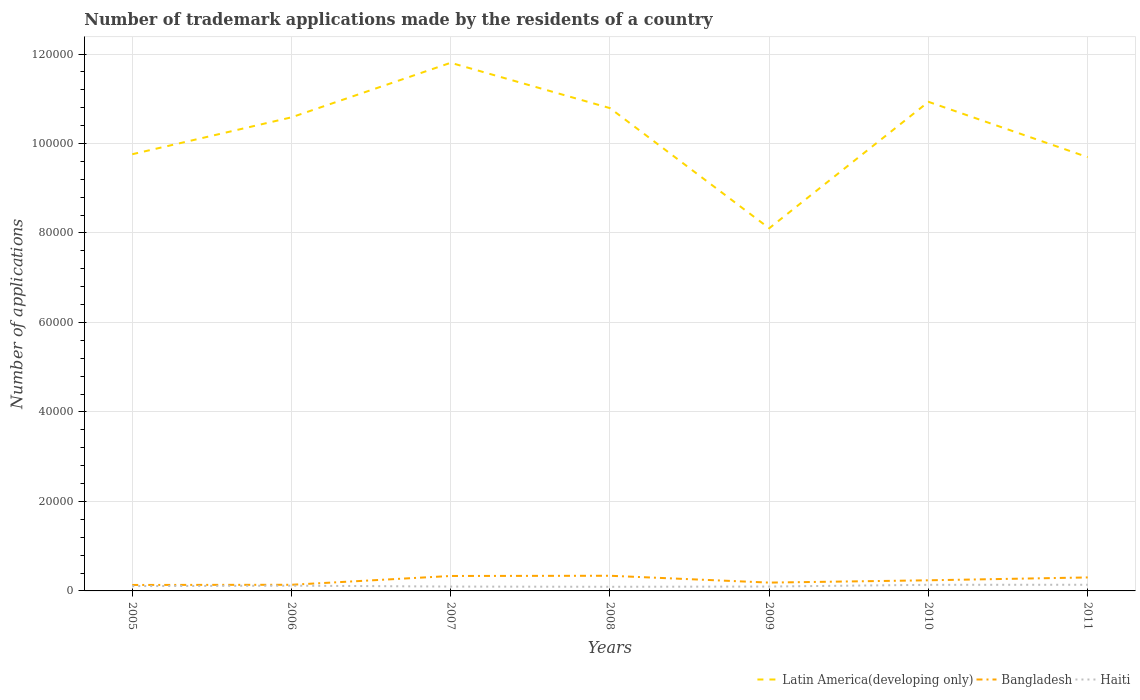Is the number of lines equal to the number of legend labels?
Make the answer very short. Yes. Across all years, what is the maximum number of trademark applications made by the residents in Latin America(developing only)?
Offer a very short reply. 8.11e+04. In which year was the number of trademark applications made by the residents in Bangladesh maximum?
Offer a very short reply. 2005. What is the total number of trademark applications made by the residents in Haiti in the graph?
Make the answer very short. 248. What is the difference between the highest and the second highest number of trademark applications made by the residents in Haiti?
Your answer should be compact. 452. What is the difference between the highest and the lowest number of trademark applications made by the residents in Bangladesh?
Give a very brief answer. 3. Is the number of trademark applications made by the residents in Bangladesh strictly greater than the number of trademark applications made by the residents in Haiti over the years?
Your answer should be very brief. No. How many years are there in the graph?
Give a very brief answer. 7. Are the values on the major ticks of Y-axis written in scientific E-notation?
Give a very brief answer. No. Does the graph contain any zero values?
Offer a terse response. No. Does the graph contain grids?
Keep it short and to the point. Yes. Where does the legend appear in the graph?
Your answer should be compact. Bottom right. How many legend labels are there?
Give a very brief answer. 3. How are the legend labels stacked?
Your response must be concise. Horizontal. What is the title of the graph?
Provide a short and direct response. Number of trademark applications made by the residents of a country. What is the label or title of the Y-axis?
Your answer should be compact. Number of applications. What is the Number of applications in Latin America(developing only) in 2005?
Offer a terse response. 9.76e+04. What is the Number of applications of Bangladesh in 2005?
Offer a very short reply. 1332. What is the Number of applications in Haiti in 2005?
Provide a succinct answer. 1079. What is the Number of applications of Latin America(developing only) in 2006?
Your answer should be compact. 1.06e+05. What is the Number of applications in Bangladesh in 2006?
Your answer should be compact. 1374. What is the Number of applications of Haiti in 2006?
Make the answer very short. 1173. What is the Number of applications in Latin America(developing only) in 2007?
Your response must be concise. 1.18e+05. What is the Number of applications in Bangladesh in 2007?
Offer a terse response. 3341. What is the Number of applications in Haiti in 2007?
Provide a succinct answer. 973. What is the Number of applications of Latin America(developing only) in 2008?
Keep it short and to the point. 1.08e+05. What is the Number of applications in Bangladesh in 2008?
Ensure brevity in your answer.  3388. What is the Number of applications in Haiti in 2008?
Ensure brevity in your answer.  925. What is the Number of applications of Latin America(developing only) in 2009?
Ensure brevity in your answer.  8.11e+04. What is the Number of applications in Bangladesh in 2009?
Provide a succinct answer. 1859. What is the Number of applications of Haiti in 2009?
Keep it short and to the point. 981. What is the Number of applications of Latin America(developing only) in 2010?
Offer a very short reply. 1.09e+05. What is the Number of applications of Bangladesh in 2010?
Your response must be concise. 2374. What is the Number of applications in Haiti in 2010?
Make the answer very short. 1365. What is the Number of applications in Latin America(developing only) in 2011?
Provide a succinct answer. 9.69e+04. What is the Number of applications of Bangladesh in 2011?
Give a very brief answer. 3013. What is the Number of applications in Haiti in 2011?
Offer a terse response. 1377. Across all years, what is the maximum Number of applications in Latin America(developing only)?
Ensure brevity in your answer.  1.18e+05. Across all years, what is the maximum Number of applications of Bangladesh?
Your response must be concise. 3388. Across all years, what is the maximum Number of applications in Haiti?
Ensure brevity in your answer.  1377. Across all years, what is the minimum Number of applications of Latin America(developing only)?
Make the answer very short. 8.11e+04. Across all years, what is the minimum Number of applications of Bangladesh?
Make the answer very short. 1332. Across all years, what is the minimum Number of applications of Haiti?
Provide a succinct answer. 925. What is the total Number of applications of Latin America(developing only) in the graph?
Your response must be concise. 7.17e+05. What is the total Number of applications of Bangladesh in the graph?
Your answer should be very brief. 1.67e+04. What is the total Number of applications of Haiti in the graph?
Keep it short and to the point. 7873. What is the difference between the Number of applications in Latin America(developing only) in 2005 and that in 2006?
Keep it short and to the point. -8250. What is the difference between the Number of applications in Bangladesh in 2005 and that in 2006?
Make the answer very short. -42. What is the difference between the Number of applications in Haiti in 2005 and that in 2006?
Make the answer very short. -94. What is the difference between the Number of applications of Latin America(developing only) in 2005 and that in 2007?
Give a very brief answer. -2.04e+04. What is the difference between the Number of applications of Bangladesh in 2005 and that in 2007?
Offer a very short reply. -2009. What is the difference between the Number of applications in Haiti in 2005 and that in 2007?
Your response must be concise. 106. What is the difference between the Number of applications of Latin America(developing only) in 2005 and that in 2008?
Ensure brevity in your answer.  -1.03e+04. What is the difference between the Number of applications of Bangladesh in 2005 and that in 2008?
Make the answer very short. -2056. What is the difference between the Number of applications of Haiti in 2005 and that in 2008?
Your response must be concise. 154. What is the difference between the Number of applications of Latin America(developing only) in 2005 and that in 2009?
Your response must be concise. 1.65e+04. What is the difference between the Number of applications in Bangladesh in 2005 and that in 2009?
Keep it short and to the point. -527. What is the difference between the Number of applications of Haiti in 2005 and that in 2009?
Ensure brevity in your answer.  98. What is the difference between the Number of applications in Latin America(developing only) in 2005 and that in 2010?
Give a very brief answer. -1.17e+04. What is the difference between the Number of applications of Bangladesh in 2005 and that in 2010?
Ensure brevity in your answer.  -1042. What is the difference between the Number of applications in Haiti in 2005 and that in 2010?
Ensure brevity in your answer.  -286. What is the difference between the Number of applications in Latin America(developing only) in 2005 and that in 2011?
Offer a very short reply. 656. What is the difference between the Number of applications of Bangladesh in 2005 and that in 2011?
Give a very brief answer. -1681. What is the difference between the Number of applications of Haiti in 2005 and that in 2011?
Make the answer very short. -298. What is the difference between the Number of applications of Latin America(developing only) in 2006 and that in 2007?
Offer a terse response. -1.22e+04. What is the difference between the Number of applications in Bangladesh in 2006 and that in 2007?
Your answer should be compact. -1967. What is the difference between the Number of applications in Latin America(developing only) in 2006 and that in 2008?
Offer a terse response. -2057. What is the difference between the Number of applications in Bangladesh in 2006 and that in 2008?
Ensure brevity in your answer.  -2014. What is the difference between the Number of applications in Haiti in 2006 and that in 2008?
Your answer should be very brief. 248. What is the difference between the Number of applications in Latin America(developing only) in 2006 and that in 2009?
Your answer should be compact. 2.48e+04. What is the difference between the Number of applications in Bangladesh in 2006 and that in 2009?
Your answer should be very brief. -485. What is the difference between the Number of applications in Haiti in 2006 and that in 2009?
Your answer should be very brief. 192. What is the difference between the Number of applications of Latin America(developing only) in 2006 and that in 2010?
Make the answer very short. -3465. What is the difference between the Number of applications of Bangladesh in 2006 and that in 2010?
Provide a succinct answer. -1000. What is the difference between the Number of applications of Haiti in 2006 and that in 2010?
Your response must be concise. -192. What is the difference between the Number of applications of Latin America(developing only) in 2006 and that in 2011?
Your response must be concise. 8906. What is the difference between the Number of applications in Bangladesh in 2006 and that in 2011?
Ensure brevity in your answer.  -1639. What is the difference between the Number of applications in Haiti in 2006 and that in 2011?
Ensure brevity in your answer.  -204. What is the difference between the Number of applications in Latin America(developing only) in 2007 and that in 2008?
Your answer should be very brief. 1.01e+04. What is the difference between the Number of applications in Bangladesh in 2007 and that in 2008?
Your answer should be very brief. -47. What is the difference between the Number of applications of Latin America(developing only) in 2007 and that in 2009?
Make the answer very short. 3.70e+04. What is the difference between the Number of applications in Bangladesh in 2007 and that in 2009?
Provide a short and direct response. 1482. What is the difference between the Number of applications in Latin America(developing only) in 2007 and that in 2010?
Provide a short and direct response. 8728. What is the difference between the Number of applications of Bangladesh in 2007 and that in 2010?
Ensure brevity in your answer.  967. What is the difference between the Number of applications in Haiti in 2007 and that in 2010?
Provide a succinct answer. -392. What is the difference between the Number of applications of Latin America(developing only) in 2007 and that in 2011?
Offer a terse response. 2.11e+04. What is the difference between the Number of applications of Bangladesh in 2007 and that in 2011?
Your response must be concise. 328. What is the difference between the Number of applications of Haiti in 2007 and that in 2011?
Your response must be concise. -404. What is the difference between the Number of applications in Latin America(developing only) in 2008 and that in 2009?
Offer a very short reply. 2.69e+04. What is the difference between the Number of applications of Bangladesh in 2008 and that in 2009?
Make the answer very short. 1529. What is the difference between the Number of applications of Haiti in 2008 and that in 2009?
Your answer should be very brief. -56. What is the difference between the Number of applications in Latin America(developing only) in 2008 and that in 2010?
Offer a terse response. -1408. What is the difference between the Number of applications of Bangladesh in 2008 and that in 2010?
Give a very brief answer. 1014. What is the difference between the Number of applications of Haiti in 2008 and that in 2010?
Offer a terse response. -440. What is the difference between the Number of applications in Latin America(developing only) in 2008 and that in 2011?
Make the answer very short. 1.10e+04. What is the difference between the Number of applications of Bangladesh in 2008 and that in 2011?
Give a very brief answer. 375. What is the difference between the Number of applications of Haiti in 2008 and that in 2011?
Offer a very short reply. -452. What is the difference between the Number of applications of Latin America(developing only) in 2009 and that in 2010?
Provide a short and direct response. -2.83e+04. What is the difference between the Number of applications of Bangladesh in 2009 and that in 2010?
Your answer should be compact. -515. What is the difference between the Number of applications in Haiti in 2009 and that in 2010?
Your answer should be compact. -384. What is the difference between the Number of applications of Latin America(developing only) in 2009 and that in 2011?
Give a very brief answer. -1.59e+04. What is the difference between the Number of applications in Bangladesh in 2009 and that in 2011?
Make the answer very short. -1154. What is the difference between the Number of applications in Haiti in 2009 and that in 2011?
Offer a very short reply. -396. What is the difference between the Number of applications in Latin America(developing only) in 2010 and that in 2011?
Offer a very short reply. 1.24e+04. What is the difference between the Number of applications of Bangladesh in 2010 and that in 2011?
Offer a very short reply. -639. What is the difference between the Number of applications of Latin America(developing only) in 2005 and the Number of applications of Bangladesh in 2006?
Keep it short and to the point. 9.62e+04. What is the difference between the Number of applications of Latin America(developing only) in 2005 and the Number of applications of Haiti in 2006?
Your response must be concise. 9.64e+04. What is the difference between the Number of applications in Bangladesh in 2005 and the Number of applications in Haiti in 2006?
Keep it short and to the point. 159. What is the difference between the Number of applications in Latin America(developing only) in 2005 and the Number of applications in Bangladesh in 2007?
Your answer should be compact. 9.43e+04. What is the difference between the Number of applications in Latin America(developing only) in 2005 and the Number of applications in Haiti in 2007?
Offer a very short reply. 9.66e+04. What is the difference between the Number of applications in Bangladesh in 2005 and the Number of applications in Haiti in 2007?
Make the answer very short. 359. What is the difference between the Number of applications of Latin America(developing only) in 2005 and the Number of applications of Bangladesh in 2008?
Provide a short and direct response. 9.42e+04. What is the difference between the Number of applications in Latin America(developing only) in 2005 and the Number of applications in Haiti in 2008?
Offer a terse response. 9.67e+04. What is the difference between the Number of applications of Bangladesh in 2005 and the Number of applications of Haiti in 2008?
Offer a terse response. 407. What is the difference between the Number of applications of Latin America(developing only) in 2005 and the Number of applications of Bangladesh in 2009?
Your answer should be very brief. 9.57e+04. What is the difference between the Number of applications of Latin America(developing only) in 2005 and the Number of applications of Haiti in 2009?
Provide a succinct answer. 9.66e+04. What is the difference between the Number of applications of Bangladesh in 2005 and the Number of applications of Haiti in 2009?
Offer a very short reply. 351. What is the difference between the Number of applications of Latin America(developing only) in 2005 and the Number of applications of Bangladesh in 2010?
Your response must be concise. 9.52e+04. What is the difference between the Number of applications of Latin America(developing only) in 2005 and the Number of applications of Haiti in 2010?
Offer a very short reply. 9.62e+04. What is the difference between the Number of applications of Bangladesh in 2005 and the Number of applications of Haiti in 2010?
Provide a short and direct response. -33. What is the difference between the Number of applications in Latin America(developing only) in 2005 and the Number of applications in Bangladesh in 2011?
Your answer should be compact. 9.46e+04. What is the difference between the Number of applications of Latin America(developing only) in 2005 and the Number of applications of Haiti in 2011?
Give a very brief answer. 9.62e+04. What is the difference between the Number of applications in Bangladesh in 2005 and the Number of applications in Haiti in 2011?
Ensure brevity in your answer.  -45. What is the difference between the Number of applications in Latin America(developing only) in 2006 and the Number of applications in Bangladesh in 2007?
Your answer should be very brief. 1.03e+05. What is the difference between the Number of applications of Latin America(developing only) in 2006 and the Number of applications of Haiti in 2007?
Your response must be concise. 1.05e+05. What is the difference between the Number of applications of Bangladesh in 2006 and the Number of applications of Haiti in 2007?
Provide a succinct answer. 401. What is the difference between the Number of applications in Latin America(developing only) in 2006 and the Number of applications in Bangladesh in 2008?
Give a very brief answer. 1.02e+05. What is the difference between the Number of applications in Latin America(developing only) in 2006 and the Number of applications in Haiti in 2008?
Offer a very short reply. 1.05e+05. What is the difference between the Number of applications of Bangladesh in 2006 and the Number of applications of Haiti in 2008?
Offer a very short reply. 449. What is the difference between the Number of applications of Latin America(developing only) in 2006 and the Number of applications of Bangladesh in 2009?
Offer a very short reply. 1.04e+05. What is the difference between the Number of applications in Latin America(developing only) in 2006 and the Number of applications in Haiti in 2009?
Make the answer very short. 1.05e+05. What is the difference between the Number of applications in Bangladesh in 2006 and the Number of applications in Haiti in 2009?
Give a very brief answer. 393. What is the difference between the Number of applications in Latin America(developing only) in 2006 and the Number of applications in Bangladesh in 2010?
Your answer should be very brief. 1.03e+05. What is the difference between the Number of applications in Latin America(developing only) in 2006 and the Number of applications in Haiti in 2010?
Your answer should be very brief. 1.04e+05. What is the difference between the Number of applications in Bangladesh in 2006 and the Number of applications in Haiti in 2010?
Your response must be concise. 9. What is the difference between the Number of applications of Latin America(developing only) in 2006 and the Number of applications of Bangladesh in 2011?
Your answer should be very brief. 1.03e+05. What is the difference between the Number of applications of Latin America(developing only) in 2006 and the Number of applications of Haiti in 2011?
Ensure brevity in your answer.  1.04e+05. What is the difference between the Number of applications of Bangladesh in 2006 and the Number of applications of Haiti in 2011?
Offer a terse response. -3. What is the difference between the Number of applications in Latin America(developing only) in 2007 and the Number of applications in Bangladesh in 2008?
Provide a short and direct response. 1.15e+05. What is the difference between the Number of applications of Latin America(developing only) in 2007 and the Number of applications of Haiti in 2008?
Offer a very short reply. 1.17e+05. What is the difference between the Number of applications in Bangladesh in 2007 and the Number of applications in Haiti in 2008?
Your response must be concise. 2416. What is the difference between the Number of applications of Latin America(developing only) in 2007 and the Number of applications of Bangladesh in 2009?
Keep it short and to the point. 1.16e+05. What is the difference between the Number of applications in Latin America(developing only) in 2007 and the Number of applications in Haiti in 2009?
Provide a succinct answer. 1.17e+05. What is the difference between the Number of applications in Bangladesh in 2007 and the Number of applications in Haiti in 2009?
Offer a very short reply. 2360. What is the difference between the Number of applications of Latin America(developing only) in 2007 and the Number of applications of Bangladesh in 2010?
Your answer should be compact. 1.16e+05. What is the difference between the Number of applications in Latin America(developing only) in 2007 and the Number of applications in Haiti in 2010?
Keep it short and to the point. 1.17e+05. What is the difference between the Number of applications of Bangladesh in 2007 and the Number of applications of Haiti in 2010?
Ensure brevity in your answer.  1976. What is the difference between the Number of applications in Latin America(developing only) in 2007 and the Number of applications in Bangladesh in 2011?
Ensure brevity in your answer.  1.15e+05. What is the difference between the Number of applications of Latin America(developing only) in 2007 and the Number of applications of Haiti in 2011?
Give a very brief answer. 1.17e+05. What is the difference between the Number of applications of Bangladesh in 2007 and the Number of applications of Haiti in 2011?
Your answer should be compact. 1964. What is the difference between the Number of applications in Latin America(developing only) in 2008 and the Number of applications in Bangladesh in 2009?
Provide a succinct answer. 1.06e+05. What is the difference between the Number of applications of Latin America(developing only) in 2008 and the Number of applications of Haiti in 2009?
Offer a terse response. 1.07e+05. What is the difference between the Number of applications in Bangladesh in 2008 and the Number of applications in Haiti in 2009?
Offer a terse response. 2407. What is the difference between the Number of applications in Latin America(developing only) in 2008 and the Number of applications in Bangladesh in 2010?
Your response must be concise. 1.06e+05. What is the difference between the Number of applications in Latin America(developing only) in 2008 and the Number of applications in Haiti in 2010?
Your answer should be compact. 1.07e+05. What is the difference between the Number of applications of Bangladesh in 2008 and the Number of applications of Haiti in 2010?
Provide a succinct answer. 2023. What is the difference between the Number of applications in Latin America(developing only) in 2008 and the Number of applications in Bangladesh in 2011?
Provide a short and direct response. 1.05e+05. What is the difference between the Number of applications in Latin America(developing only) in 2008 and the Number of applications in Haiti in 2011?
Offer a very short reply. 1.07e+05. What is the difference between the Number of applications in Bangladesh in 2008 and the Number of applications in Haiti in 2011?
Give a very brief answer. 2011. What is the difference between the Number of applications in Latin America(developing only) in 2009 and the Number of applications in Bangladesh in 2010?
Your answer should be compact. 7.87e+04. What is the difference between the Number of applications of Latin America(developing only) in 2009 and the Number of applications of Haiti in 2010?
Provide a short and direct response. 7.97e+04. What is the difference between the Number of applications of Bangladesh in 2009 and the Number of applications of Haiti in 2010?
Provide a short and direct response. 494. What is the difference between the Number of applications in Latin America(developing only) in 2009 and the Number of applications in Bangladesh in 2011?
Offer a terse response. 7.80e+04. What is the difference between the Number of applications in Latin America(developing only) in 2009 and the Number of applications in Haiti in 2011?
Your answer should be very brief. 7.97e+04. What is the difference between the Number of applications of Bangladesh in 2009 and the Number of applications of Haiti in 2011?
Your answer should be compact. 482. What is the difference between the Number of applications in Latin America(developing only) in 2010 and the Number of applications in Bangladesh in 2011?
Provide a succinct answer. 1.06e+05. What is the difference between the Number of applications in Latin America(developing only) in 2010 and the Number of applications in Haiti in 2011?
Keep it short and to the point. 1.08e+05. What is the difference between the Number of applications of Bangladesh in 2010 and the Number of applications of Haiti in 2011?
Give a very brief answer. 997. What is the average Number of applications in Latin America(developing only) per year?
Keep it short and to the point. 1.02e+05. What is the average Number of applications in Bangladesh per year?
Provide a succinct answer. 2383. What is the average Number of applications of Haiti per year?
Provide a short and direct response. 1124.71. In the year 2005, what is the difference between the Number of applications of Latin America(developing only) and Number of applications of Bangladesh?
Give a very brief answer. 9.63e+04. In the year 2005, what is the difference between the Number of applications of Latin America(developing only) and Number of applications of Haiti?
Provide a succinct answer. 9.65e+04. In the year 2005, what is the difference between the Number of applications of Bangladesh and Number of applications of Haiti?
Your response must be concise. 253. In the year 2006, what is the difference between the Number of applications in Latin America(developing only) and Number of applications in Bangladesh?
Offer a terse response. 1.04e+05. In the year 2006, what is the difference between the Number of applications in Latin America(developing only) and Number of applications in Haiti?
Provide a succinct answer. 1.05e+05. In the year 2006, what is the difference between the Number of applications in Bangladesh and Number of applications in Haiti?
Your response must be concise. 201. In the year 2007, what is the difference between the Number of applications of Latin America(developing only) and Number of applications of Bangladesh?
Offer a terse response. 1.15e+05. In the year 2007, what is the difference between the Number of applications of Latin America(developing only) and Number of applications of Haiti?
Your answer should be very brief. 1.17e+05. In the year 2007, what is the difference between the Number of applications in Bangladesh and Number of applications in Haiti?
Your answer should be very brief. 2368. In the year 2008, what is the difference between the Number of applications of Latin America(developing only) and Number of applications of Bangladesh?
Provide a succinct answer. 1.05e+05. In the year 2008, what is the difference between the Number of applications of Latin America(developing only) and Number of applications of Haiti?
Keep it short and to the point. 1.07e+05. In the year 2008, what is the difference between the Number of applications of Bangladesh and Number of applications of Haiti?
Your response must be concise. 2463. In the year 2009, what is the difference between the Number of applications of Latin America(developing only) and Number of applications of Bangladesh?
Your answer should be very brief. 7.92e+04. In the year 2009, what is the difference between the Number of applications in Latin America(developing only) and Number of applications in Haiti?
Offer a terse response. 8.01e+04. In the year 2009, what is the difference between the Number of applications in Bangladesh and Number of applications in Haiti?
Keep it short and to the point. 878. In the year 2010, what is the difference between the Number of applications of Latin America(developing only) and Number of applications of Bangladesh?
Your answer should be compact. 1.07e+05. In the year 2010, what is the difference between the Number of applications of Latin America(developing only) and Number of applications of Haiti?
Ensure brevity in your answer.  1.08e+05. In the year 2010, what is the difference between the Number of applications in Bangladesh and Number of applications in Haiti?
Your response must be concise. 1009. In the year 2011, what is the difference between the Number of applications in Latin America(developing only) and Number of applications in Bangladesh?
Your response must be concise. 9.39e+04. In the year 2011, what is the difference between the Number of applications in Latin America(developing only) and Number of applications in Haiti?
Your response must be concise. 9.56e+04. In the year 2011, what is the difference between the Number of applications in Bangladesh and Number of applications in Haiti?
Your response must be concise. 1636. What is the ratio of the Number of applications in Latin America(developing only) in 2005 to that in 2006?
Make the answer very short. 0.92. What is the ratio of the Number of applications of Bangladesh in 2005 to that in 2006?
Give a very brief answer. 0.97. What is the ratio of the Number of applications of Haiti in 2005 to that in 2006?
Offer a terse response. 0.92. What is the ratio of the Number of applications of Latin America(developing only) in 2005 to that in 2007?
Ensure brevity in your answer.  0.83. What is the ratio of the Number of applications in Bangladesh in 2005 to that in 2007?
Make the answer very short. 0.4. What is the ratio of the Number of applications of Haiti in 2005 to that in 2007?
Keep it short and to the point. 1.11. What is the ratio of the Number of applications of Latin America(developing only) in 2005 to that in 2008?
Make the answer very short. 0.9. What is the ratio of the Number of applications of Bangladesh in 2005 to that in 2008?
Provide a short and direct response. 0.39. What is the ratio of the Number of applications in Haiti in 2005 to that in 2008?
Your answer should be very brief. 1.17. What is the ratio of the Number of applications of Latin America(developing only) in 2005 to that in 2009?
Make the answer very short. 1.2. What is the ratio of the Number of applications of Bangladesh in 2005 to that in 2009?
Ensure brevity in your answer.  0.72. What is the ratio of the Number of applications of Haiti in 2005 to that in 2009?
Ensure brevity in your answer.  1.1. What is the ratio of the Number of applications in Latin America(developing only) in 2005 to that in 2010?
Offer a very short reply. 0.89. What is the ratio of the Number of applications in Bangladesh in 2005 to that in 2010?
Provide a short and direct response. 0.56. What is the ratio of the Number of applications in Haiti in 2005 to that in 2010?
Keep it short and to the point. 0.79. What is the ratio of the Number of applications of Latin America(developing only) in 2005 to that in 2011?
Give a very brief answer. 1.01. What is the ratio of the Number of applications in Bangladesh in 2005 to that in 2011?
Give a very brief answer. 0.44. What is the ratio of the Number of applications of Haiti in 2005 to that in 2011?
Provide a succinct answer. 0.78. What is the ratio of the Number of applications in Latin America(developing only) in 2006 to that in 2007?
Ensure brevity in your answer.  0.9. What is the ratio of the Number of applications in Bangladesh in 2006 to that in 2007?
Provide a succinct answer. 0.41. What is the ratio of the Number of applications of Haiti in 2006 to that in 2007?
Provide a succinct answer. 1.21. What is the ratio of the Number of applications of Latin America(developing only) in 2006 to that in 2008?
Your response must be concise. 0.98. What is the ratio of the Number of applications of Bangladesh in 2006 to that in 2008?
Keep it short and to the point. 0.41. What is the ratio of the Number of applications in Haiti in 2006 to that in 2008?
Offer a terse response. 1.27. What is the ratio of the Number of applications of Latin America(developing only) in 2006 to that in 2009?
Provide a short and direct response. 1.31. What is the ratio of the Number of applications of Bangladesh in 2006 to that in 2009?
Your answer should be very brief. 0.74. What is the ratio of the Number of applications of Haiti in 2006 to that in 2009?
Give a very brief answer. 1.2. What is the ratio of the Number of applications in Latin America(developing only) in 2006 to that in 2010?
Make the answer very short. 0.97. What is the ratio of the Number of applications of Bangladesh in 2006 to that in 2010?
Offer a terse response. 0.58. What is the ratio of the Number of applications of Haiti in 2006 to that in 2010?
Your response must be concise. 0.86. What is the ratio of the Number of applications of Latin America(developing only) in 2006 to that in 2011?
Your answer should be compact. 1.09. What is the ratio of the Number of applications of Bangladesh in 2006 to that in 2011?
Keep it short and to the point. 0.46. What is the ratio of the Number of applications in Haiti in 2006 to that in 2011?
Make the answer very short. 0.85. What is the ratio of the Number of applications of Latin America(developing only) in 2007 to that in 2008?
Ensure brevity in your answer.  1.09. What is the ratio of the Number of applications of Bangladesh in 2007 to that in 2008?
Your answer should be very brief. 0.99. What is the ratio of the Number of applications of Haiti in 2007 to that in 2008?
Provide a short and direct response. 1.05. What is the ratio of the Number of applications of Latin America(developing only) in 2007 to that in 2009?
Give a very brief answer. 1.46. What is the ratio of the Number of applications in Bangladesh in 2007 to that in 2009?
Provide a short and direct response. 1.8. What is the ratio of the Number of applications in Haiti in 2007 to that in 2009?
Ensure brevity in your answer.  0.99. What is the ratio of the Number of applications of Latin America(developing only) in 2007 to that in 2010?
Your answer should be compact. 1.08. What is the ratio of the Number of applications in Bangladesh in 2007 to that in 2010?
Your response must be concise. 1.41. What is the ratio of the Number of applications of Haiti in 2007 to that in 2010?
Offer a very short reply. 0.71. What is the ratio of the Number of applications in Latin America(developing only) in 2007 to that in 2011?
Your response must be concise. 1.22. What is the ratio of the Number of applications in Bangladesh in 2007 to that in 2011?
Your response must be concise. 1.11. What is the ratio of the Number of applications in Haiti in 2007 to that in 2011?
Your answer should be very brief. 0.71. What is the ratio of the Number of applications of Latin America(developing only) in 2008 to that in 2009?
Provide a succinct answer. 1.33. What is the ratio of the Number of applications of Bangladesh in 2008 to that in 2009?
Offer a terse response. 1.82. What is the ratio of the Number of applications in Haiti in 2008 to that in 2009?
Your response must be concise. 0.94. What is the ratio of the Number of applications of Latin America(developing only) in 2008 to that in 2010?
Offer a very short reply. 0.99. What is the ratio of the Number of applications in Bangladesh in 2008 to that in 2010?
Your answer should be very brief. 1.43. What is the ratio of the Number of applications in Haiti in 2008 to that in 2010?
Keep it short and to the point. 0.68. What is the ratio of the Number of applications in Latin America(developing only) in 2008 to that in 2011?
Make the answer very short. 1.11. What is the ratio of the Number of applications in Bangladesh in 2008 to that in 2011?
Your response must be concise. 1.12. What is the ratio of the Number of applications of Haiti in 2008 to that in 2011?
Ensure brevity in your answer.  0.67. What is the ratio of the Number of applications of Latin America(developing only) in 2009 to that in 2010?
Your answer should be compact. 0.74. What is the ratio of the Number of applications of Bangladesh in 2009 to that in 2010?
Offer a terse response. 0.78. What is the ratio of the Number of applications of Haiti in 2009 to that in 2010?
Provide a succinct answer. 0.72. What is the ratio of the Number of applications of Latin America(developing only) in 2009 to that in 2011?
Offer a very short reply. 0.84. What is the ratio of the Number of applications in Bangladesh in 2009 to that in 2011?
Make the answer very short. 0.62. What is the ratio of the Number of applications of Haiti in 2009 to that in 2011?
Provide a succinct answer. 0.71. What is the ratio of the Number of applications in Latin America(developing only) in 2010 to that in 2011?
Your answer should be very brief. 1.13. What is the ratio of the Number of applications in Bangladesh in 2010 to that in 2011?
Offer a terse response. 0.79. What is the ratio of the Number of applications in Haiti in 2010 to that in 2011?
Your response must be concise. 0.99. What is the difference between the highest and the second highest Number of applications of Latin America(developing only)?
Make the answer very short. 8728. What is the difference between the highest and the second highest Number of applications in Bangladesh?
Offer a very short reply. 47. What is the difference between the highest and the lowest Number of applications of Latin America(developing only)?
Make the answer very short. 3.70e+04. What is the difference between the highest and the lowest Number of applications in Bangladesh?
Keep it short and to the point. 2056. What is the difference between the highest and the lowest Number of applications in Haiti?
Give a very brief answer. 452. 